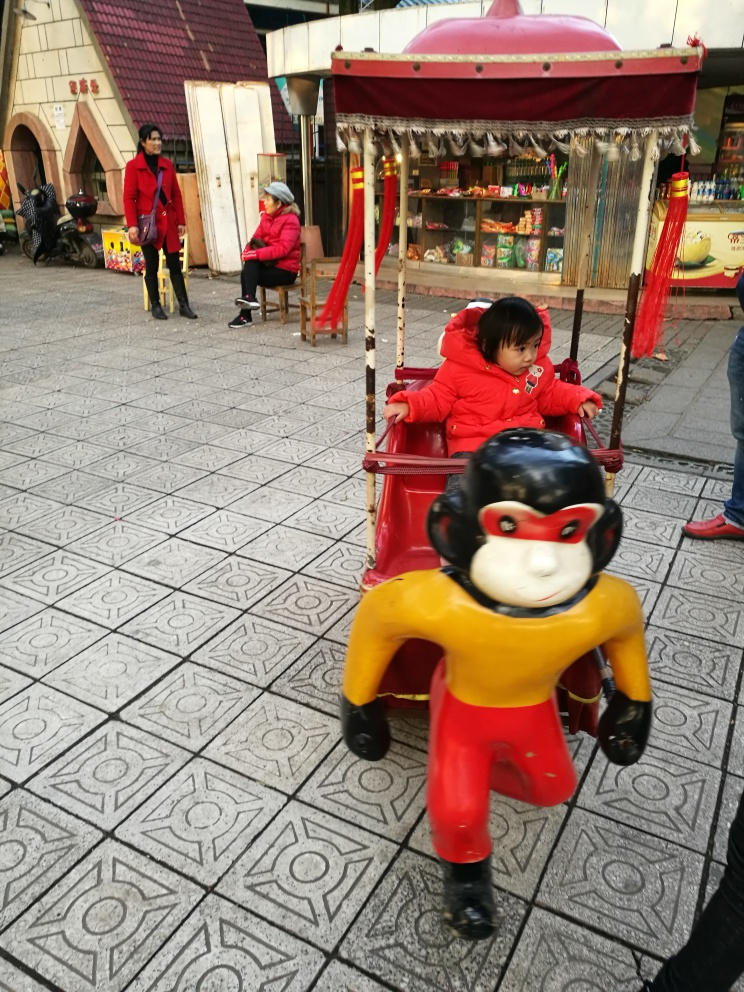Can you describe the activity taking place? In the image, a child is seated in a toy vehicle ride, often found in public marketplaces for children's entertainment, while nearby adults appear to be engaged in casual observation or conversation. 